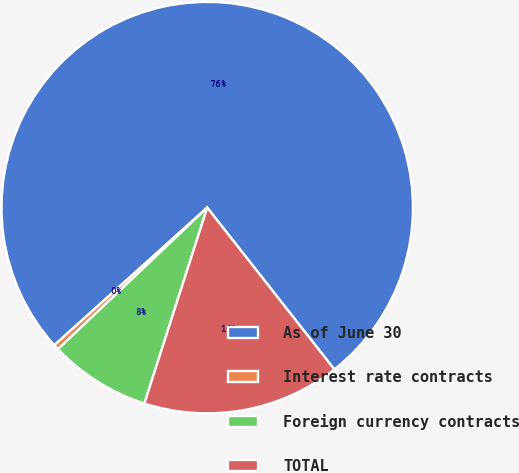Convert chart. <chart><loc_0><loc_0><loc_500><loc_500><pie_chart><fcel>As of June 30<fcel>Interest rate contracts<fcel>Foreign currency contracts<fcel>TOTAL<nl><fcel>76.06%<fcel>0.42%<fcel>7.98%<fcel>15.54%<nl></chart> 